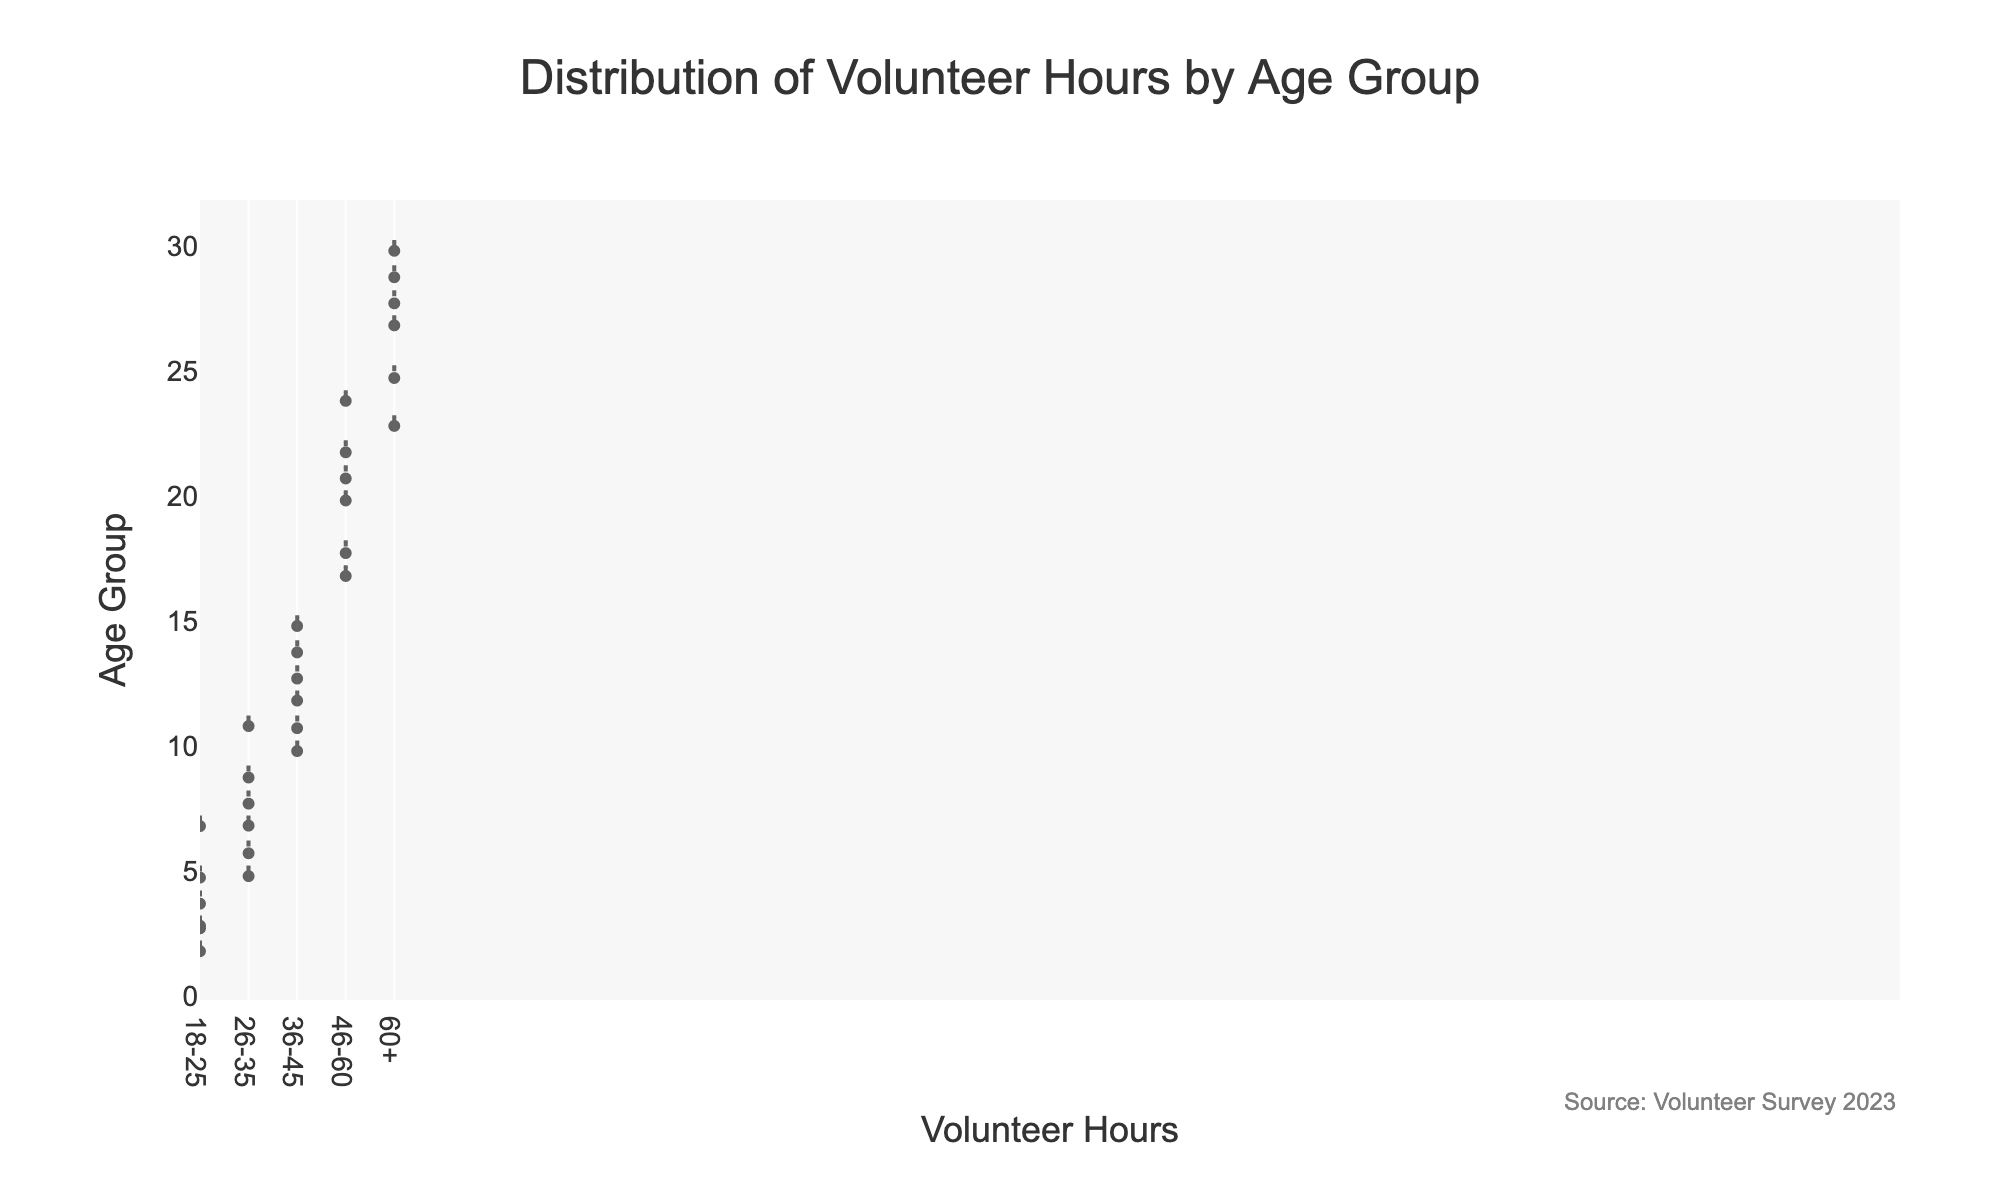what is the title of the chart? The title of the chart is typically located at the top and is presented in a larger, bold font to highlight its importance. In this case, the title reads "Distribution of Volunteer Hours by Age Group".
Answer: Distribution of Volunteer Hours by Age Group what is the age group with the highest median volunteer hours? To find the age group with the highest median volunteer hours, observe the white line in the middle of each violin plot, which represents the median. The median for the 60+ age group is the highest among all.
Answer: 60+ how many age groups are represented in the chart? The age groups can be identified by looking at the labels on the y-axis, each of which represents a distinct group. Here, there are five age groups: 18-25, 26-35, 36-45, 46-60, and 60+.
Answer: 5 which age group shows the widest range of volunteer hours? The range of volunteer hours for each age group can be determined by looking at the length of each violin plot. The 60+ age group shows the widest range, extending from 23 to 30 hours.
Answer: 60+ what is the mean volunteer hours for the age group 36-45? The mean is indicated by the horizontal black line in the middle of the white line within each violin plot. For the 36-45 age group, the mean aligns near 12.5 hours.
Answer: approximately 12.5 hours which age group has the greatest variability in volunteer hours? The variability is represented by the spread and width of the violin plots. The 60+ age group has the greatest variability with a wide range and more data points spread across it.
Answer: 60+ Which age group has the smallest range of volunteer hours? To identify the smallest range, look at the length of the violin plots; the shortest plot will have the smallest range. The 18-25 age group shows the smallest range from 2 to 7 hours.
Answer: 18-25 how is the data for the age group 26-35 distributed? The distribution can be analyzed by looking at the shape of the violin plot. The 26-35 age group shows a relatively symmetrical distribution centered around 7 and 8 hours, indicating a balanced volunteer hour’s distribution around these values.
Answer: symmetric around 7 and 8 hours how does the distribution of volunteer hours for the 46-60 age group compare to the 60+ age group? Compare the shape and spread of the violin plots for both age groups. The 46-60 age group has a less spread and slightly lower range compared to the 60+ age group which has a wider range and more variability in the volunteer hours.
Answer: less spread and lower range Which age group has the most consistent (least variable) volunteer hours? Consistency can be observed by looking at the narrowest and least spread violin plot. The 18-25 age group exhibits the most consistent volunteer hours, as its plot is narrow and concentrated.
Answer: 18-25 